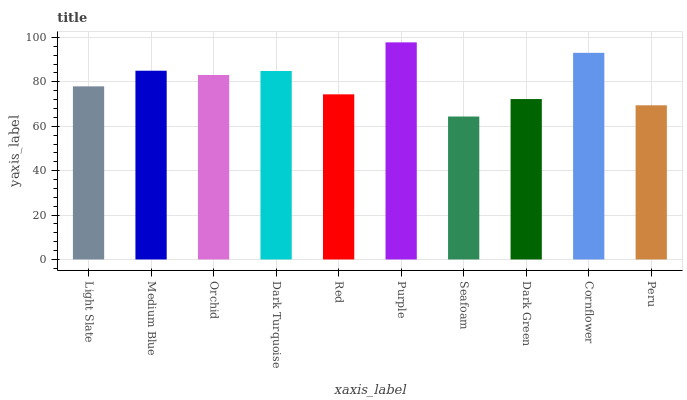Is Medium Blue the minimum?
Answer yes or no. No. Is Medium Blue the maximum?
Answer yes or no. No. Is Medium Blue greater than Light Slate?
Answer yes or no. Yes. Is Light Slate less than Medium Blue?
Answer yes or no. Yes. Is Light Slate greater than Medium Blue?
Answer yes or no. No. Is Medium Blue less than Light Slate?
Answer yes or no. No. Is Orchid the high median?
Answer yes or no. Yes. Is Light Slate the low median?
Answer yes or no. Yes. Is Dark Turquoise the high median?
Answer yes or no. No. Is Cornflower the low median?
Answer yes or no. No. 